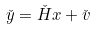Convert formula to latex. <formula><loc_0><loc_0><loc_500><loc_500>\check { y } = \check { H } x + \check { v }</formula> 